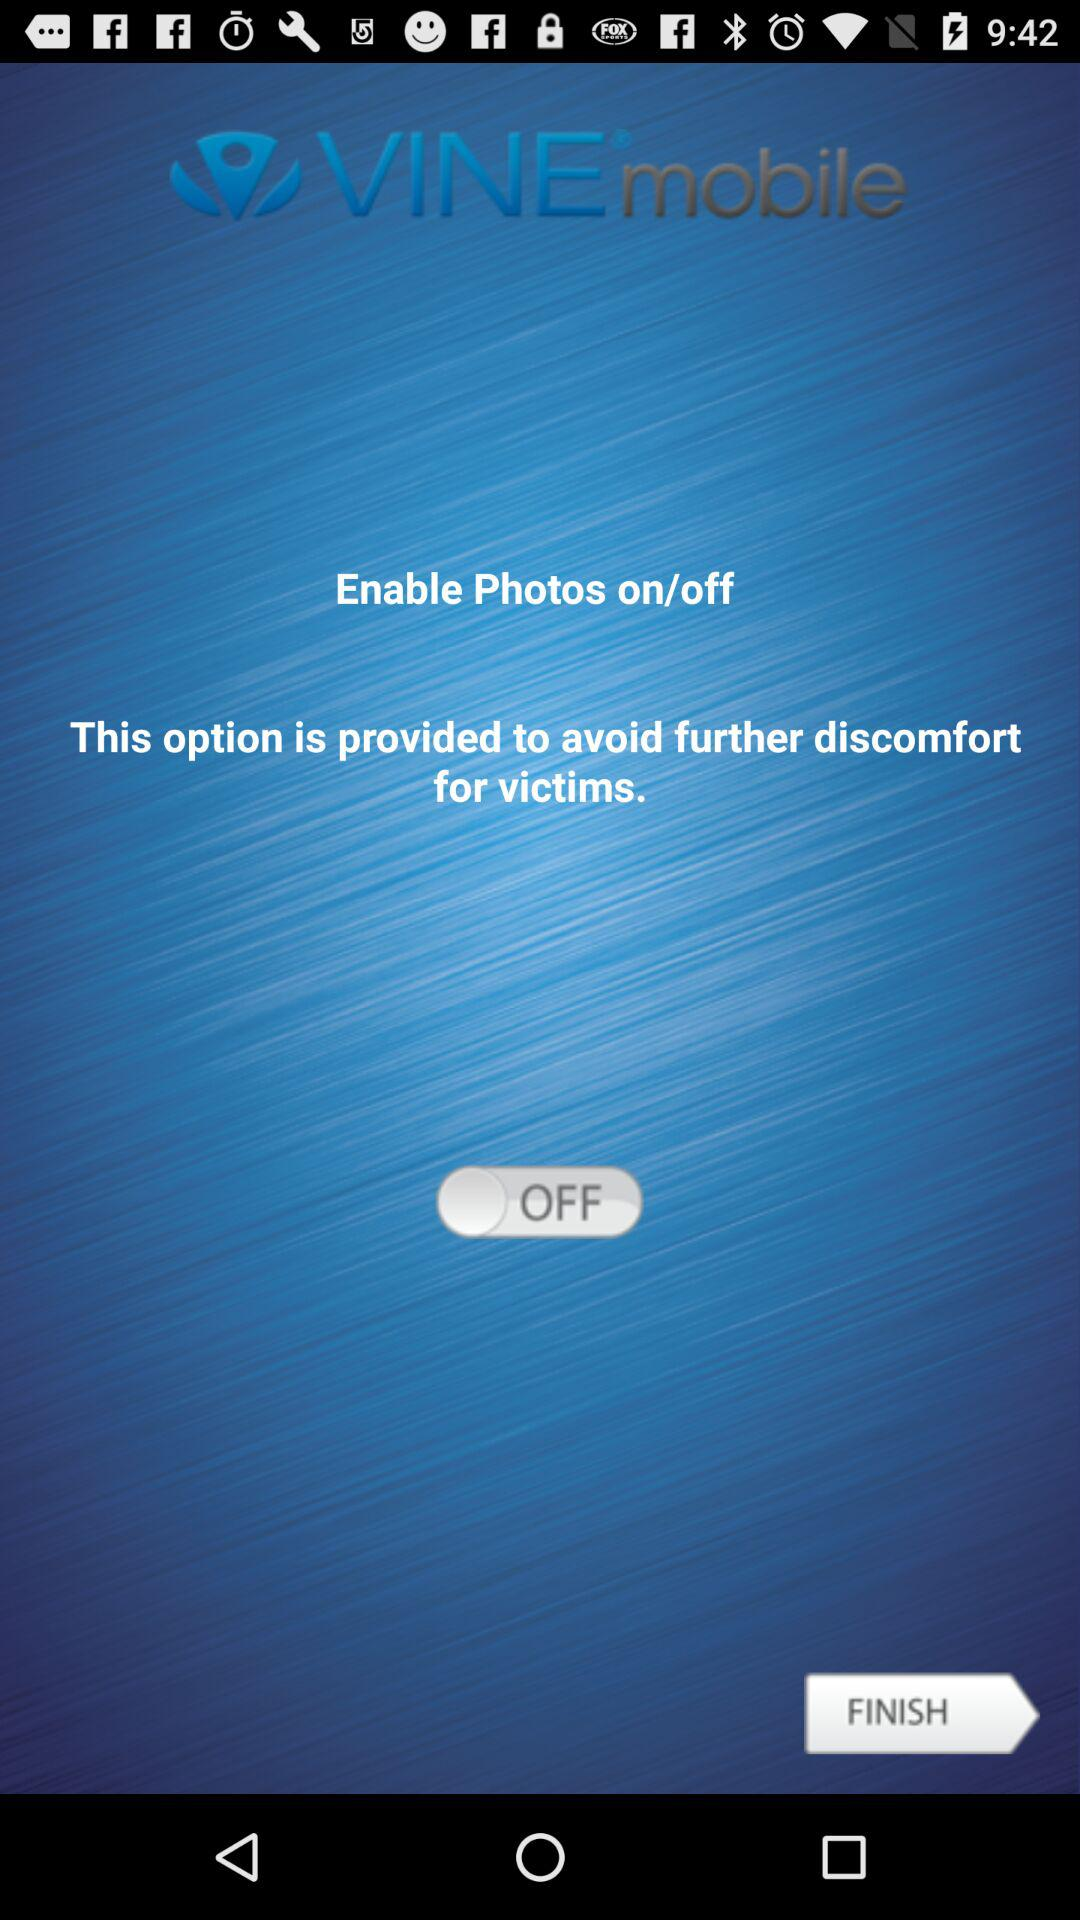What is the application name? The application name is "VINE mobile". 